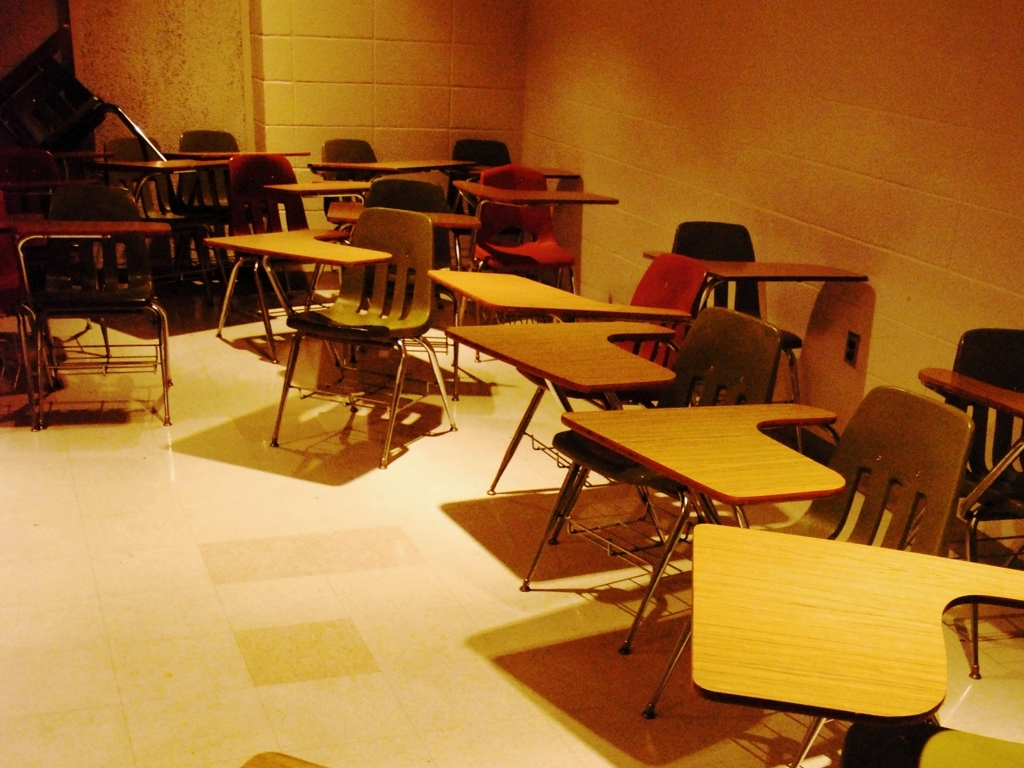What is the quality of this image? The quality of the image is passable, with a score of 'B'. While the lighting appears sufficient and the key elements are discernible, there appears to be some graininess and the colors are not very vivid. The focus and resolution are adequate for identifying the scene as a classroom with desks but could be improved for finer details. 